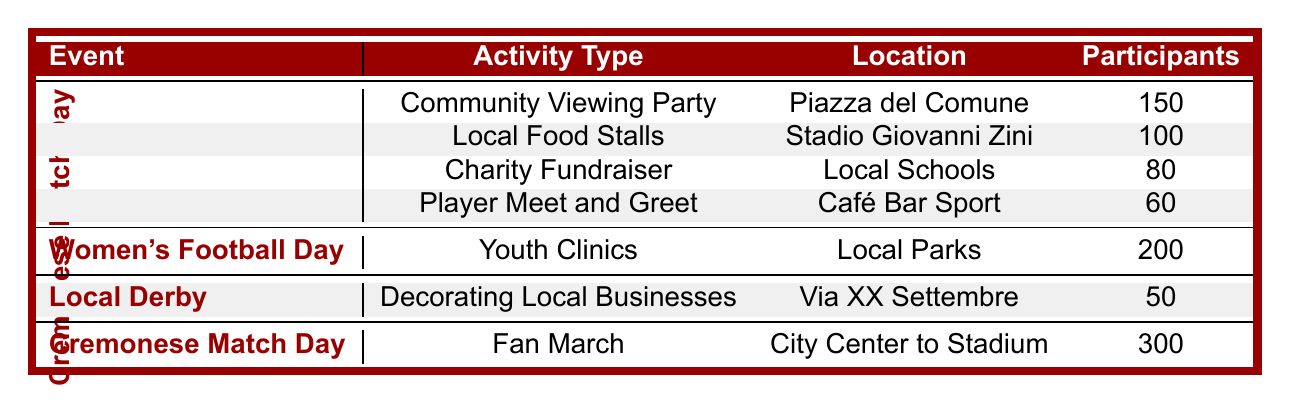What is the total number of participants for "Cremonese Match Day"? To find the total participants for "Cremonese Match Day," I will add the number of participants listed under this event: 150 (Community Viewing Party) + 100 (Local Food Stalls) + 80 (Charity Fundraiser) + 60 (Player Meet and Greet) + 300 (Fan March). The sum is 150 + 100 + 80 + 60 + 300 = 690.
Answer: 690 Which event had the highest number of participants and how many were there? Looking at the table, "Fan March" under "Cremonese Match Day" has the highest number of participants with 300. I will check each event's highest participant count to confirm that this is the maximum. No other event exceeds 300.
Answer: Fan March, 300 Is there a community engagement activity in the park related to football events? Yes, "Youth Clinics" is an activity related to women's football held in Local Parks, and it engages the community. This answers the question of whether such an activity exists.
Answer: Yes What is the average number of participants for activities on "Cremonese Match Day"? To find the average, I will add the participant counts for all activities under "Cremonese Match Day": 150 + 100 + 80 + 60 + 300 = 690 participants. There are four distinct activities (excluding the Fan March since it's listed separately). Hence, the average is 690 / 4 = 172.5.
Answer: 172.5 Did "Women's Football Day" have more participants than "Local Derby"? "Women's Football Day" had 200 participants for "Youth Clinics," while "Local Derby" had 50 participants for "Decorating Local Businesses." Comparing these values, 200 is greater than 50.
Answer: Yes What was the location for the "Player Meet and Greet" activity? By checking the "Cremonese Match Day" section in the table, the "Player Meet and Greet" activity is located at "Café Bar Sport."
Answer: Café Bar Sport How many activities had more than 100 participants? I will review each activity's participant count and count those with more than 100 participants: "Community Viewing Party" (150), "Youth Clinics" (200), and "Fan March" (300) total to 3 activities with more than 100 participants.
Answer: 3 What is the difference in participants between "Youth Clinics" and the "Charity Fundraiser"? The "Youth Clinics" had 200 participants and the "Charity Fundraiser" had 80 participants. The difference is calculated as 200 - 80 = 120.
Answer: 120 Are there any activities listed on multiple dates? In this table, no activities appear to be listed on multiple dates as each event occurs on a unique date.
Answer: No 